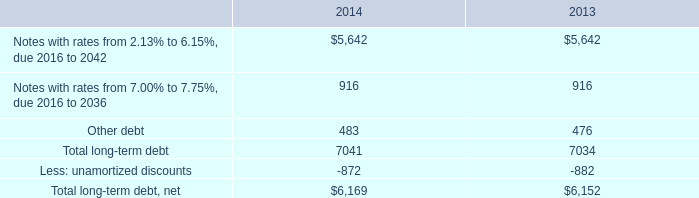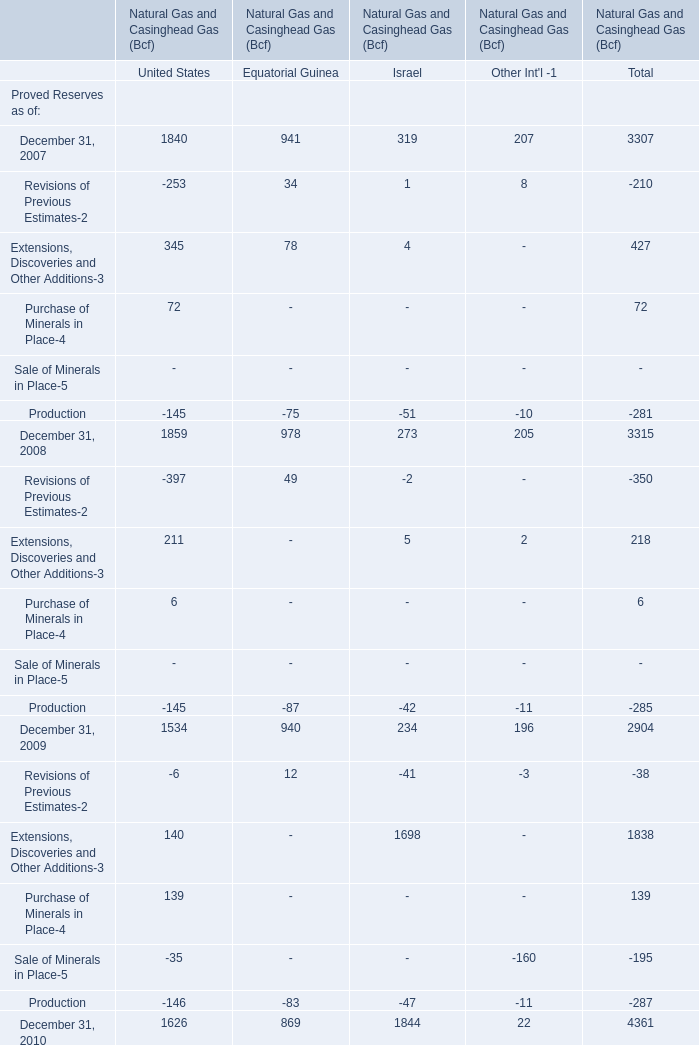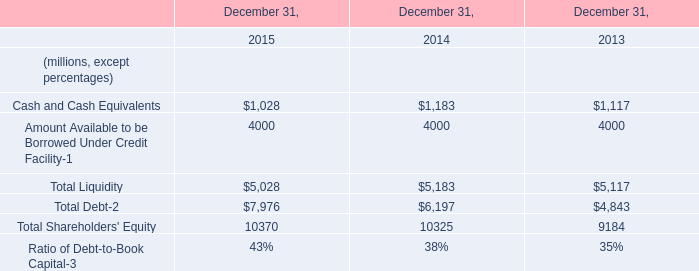what was the average total long-term debt from 2013 to 2014 
Computations: ((6169 - 6152) / 2)
Answer: 8.5. 